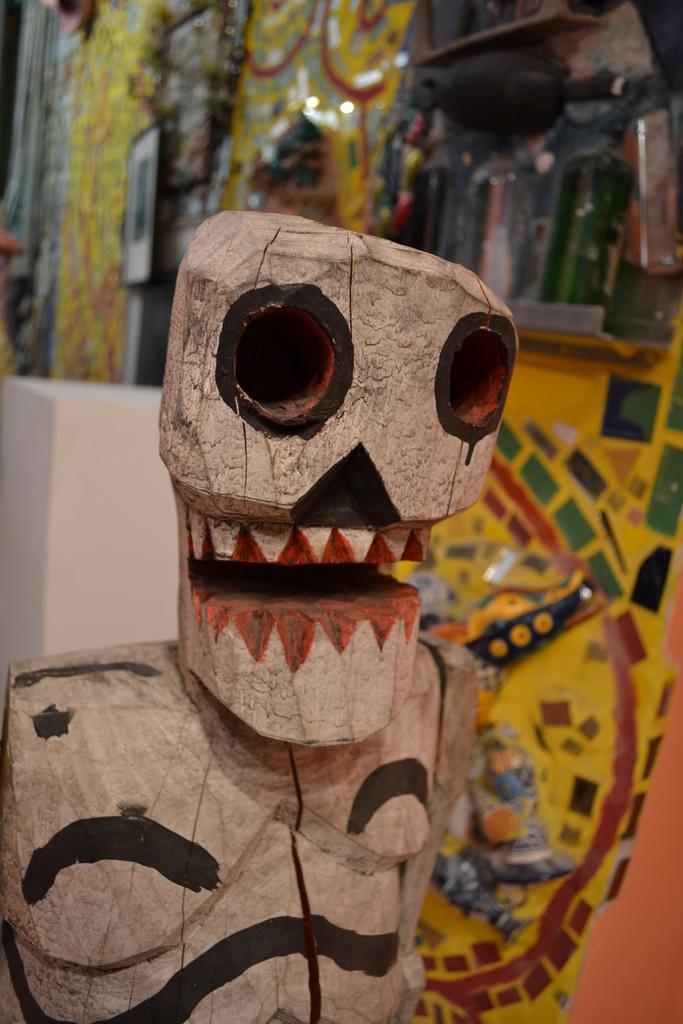What type of toy is in the picture? There is a wooden toy in the picture. What can be observed about the appearance of the wooden toy? The wooden toy has colors on it. What else can be seen in the background of the picture? There are other objects in the background of the picture. What type of fan is visible in the picture? There is no fan present in the picture; it features a wooden toy with colors on it and other objects in the background. What time of day is depicted in the picture? The provided facts do not give us enough information to determine the time of day depicted in the picture. 